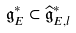<formula> <loc_0><loc_0><loc_500><loc_500>\mathfrak { g } _ { E } ^ { \ast } \subset \widehat { \mathfrak { g } } _ { E , l } ^ { \ast }</formula> 